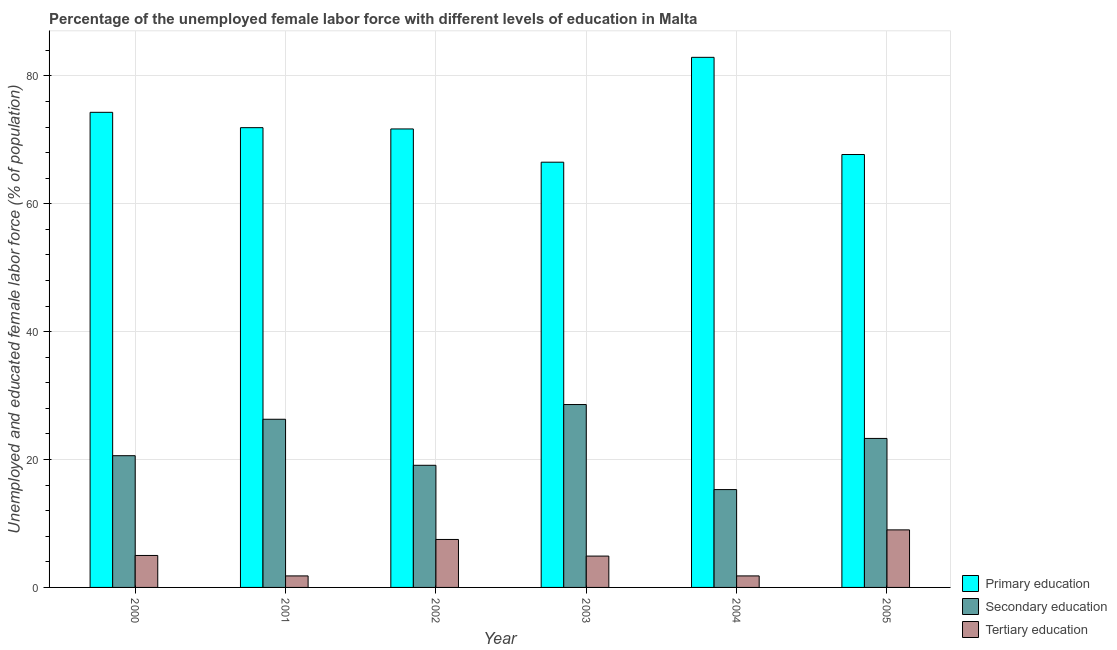How many different coloured bars are there?
Provide a succinct answer. 3. How many groups of bars are there?
Offer a very short reply. 6. Are the number of bars per tick equal to the number of legend labels?
Provide a short and direct response. Yes. Are the number of bars on each tick of the X-axis equal?
Ensure brevity in your answer.  Yes. How many bars are there on the 4th tick from the right?
Ensure brevity in your answer.  3. In how many cases, is the number of bars for a given year not equal to the number of legend labels?
Offer a terse response. 0. What is the percentage of female labor force who received tertiary education in 2003?
Ensure brevity in your answer.  4.9. Across all years, what is the maximum percentage of female labor force who received secondary education?
Your answer should be very brief. 28.6. Across all years, what is the minimum percentage of female labor force who received primary education?
Your answer should be compact. 66.5. In which year was the percentage of female labor force who received secondary education maximum?
Provide a short and direct response. 2003. In which year was the percentage of female labor force who received secondary education minimum?
Give a very brief answer. 2004. What is the total percentage of female labor force who received secondary education in the graph?
Keep it short and to the point. 133.2. What is the difference between the percentage of female labor force who received tertiary education in 2001 and that in 2002?
Your response must be concise. -5.7. What is the difference between the percentage of female labor force who received secondary education in 2003 and the percentage of female labor force who received tertiary education in 2004?
Offer a very short reply. 13.3. What is the average percentage of female labor force who received tertiary education per year?
Provide a succinct answer. 5. In the year 2001, what is the difference between the percentage of female labor force who received secondary education and percentage of female labor force who received primary education?
Provide a short and direct response. 0. What is the ratio of the percentage of female labor force who received tertiary education in 2001 to that in 2003?
Offer a very short reply. 0.37. Is the percentage of female labor force who received tertiary education in 2004 less than that in 2005?
Your answer should be very brief. Yes. Is the difference between the percentage of female labor force who received primary education in 2000 and 2003 greater than the difference between the percentage of female labor force who received tertiary education in 2000 and 2003?
Your answer should be compact. No. What is the difference between the highest and the lowest percentage of female labor force who received primary education?
Your answer should be very brief. 16.4. In how many years, is the percentage of female labor force who received tertiary education greater than the average percentage of female labor force who received tertiary education taken over all years?
Make the answer very short. 3. What does the 2nd bar from the left in 2002 represents?
Offer a very short reply. Secondary education. What does the 2nd bar from the right in 2004 represents?
Offer a terse response. Secondary education. Is it the case that in every year, the sum of the percentage of female labor force who received primary education and percentage of female labor force who received secondary education is greater than the percentage of female labor force who received tertiary education?
Offer a very short reply. Yes. How many years are there in the graph?
Ensure brevity in your answer.  6. What is the difference between two consecutive major ticks on the Y-axis?
Your response must be concise. 20. Does the graph contain any zero values?
Keep it short and to the point. No. Does the graph contain grids?
Ensure brevity in your answer.  Yes. Where does the legend appear in the graph?
Your response must be concise. Bottom right. What is the title of the graph?
Your answer should be compact. Percentage of the unemployed female labor force with different levels of education in Malta. Does "Manufactures" appear as one of the legend labels in the graph?
Offer a very short reply. No. What is the label or title of the X-axis?
Provide a succinct answer. Year. What is the label or title of the Y-axis?
Your answer should be compact. Unemployed and educated female labor force (% of population). What is the Unemployed and educated female labor force (% of population) in Primary education in 2000?
Offer a terse response. 74.3. What is the Unemployed and educated female labor force (% of population) of Secondary education in 2000?
Provide a short and direct response. 20.6. What is the Unemployed and educated female labor force (% of population) of Tertiary education in 2000?
Provide a short and direct response. 5. What is the Unemployed and educated female labor force (% of population) in Primary education in 2001?
Your answer should be compact. 71.9. What is the Unemployed and educated female labor force (% of population) in Secondary education in 2001?
Your answer should be very brief. 26.3. What is the Unemployed and educated female labor force (% of population) of Tertiary education in 2001?
Provide a succinct answer. 1.8. What is the Unemployed and educated female labor force (% of population) of Primary education in 2002?
Your answer should be very brief. 71.7. What is the Unemployed and educated female labor force (% of population) in Secondary education in 2002?
Your response must be concise. 19.1. What is the Unemployed and educated female labor force (% of population) in Tertiary education in 2002?
Make the answer very short. 7.5. What is the Unemployed and educated female labor force (% of population) in Primary education in 2003?
Make the answer very short. 66.5. What is the Unemployed and educated female labor force (% of population) in Secondary education in 2003?
Offer a terse response. 28.6. What is the Unemployed and educated female labor force (% of population) of Tertiary education in 2003?
Keep it short and to the point. 4.9. What is the Unemployed and educated female labor force (% of population) of Primary education in 2004?
Offer a very short reply. 82.9. What is the Unemployed and educated female labor force (% of population) in Secondary education in 2004?
Provide a short and direct response. 15.3. What is the Unemployed and educated female labor force (% of population) of Tertiary education in 2004?
Offer a terse response. 1.8. What is the Unemployed and educated female labor force (% of population) of Primary education in 2005?
Make the answer very short. 67.7. What is the Unemployed and educated female labor force (% of population) in Secondary education in 2005?
Keep it short and to the point. 23.3. Across all years, what is the maximum Unemployed and educated female labor force (% of population) in Primary education?
Offer a very short reply. 82.9. Across all years, what is the maximum Unemployed and educated female labor force (% of population) of Secondary education?
Offer a very short reply. 28.6. Across all years, what is the minimum Unemployed and educated female labor force (% of population) of Primary education?
Provide a short and direct response. 66.5. Across all years, what is the minimum Unemployed and educated female labor force (% of population) of Secondary education?
Make the answer very short. 15.3. Across all years, what is the minimum Unemployed and educated female labor force (% of population) of Tertiary education?
Offer a very short reply. 1.8. What is the total Unemployed and educated female labor force (% of population) in Primary education in the graph?
Your answer should be compact. 435. What is the total Unemployed and educated female labor force (% of population) of Secondary education in the graph?
Give a very brief answer. 133.2. What is the total Unemployed and educated female labor force (% of population) of Tertiary education in the graph?
Give a very brief answer. 30. What is the difference between the Unemployed and educated female labor force (% of population) of Tertiary education in 2000 and that in 2001?
Make the answer very short. 3.2. What is the difference between the Unemployed and educated female labor force (% of population) in Primary education in 2000 and that in 2002?
Provide a short and direct response. 2.6. What is the difference between the Unemployed and educated female labor force (% of population) in Secondary education in 2000 and that in 2002?
Ensure brevity in your answer.  1.5. What is the difference between the Unemployed and educated female labor force (% of population) of Tertiary education in 2000 and that in 2002?
Your response must be concise. -2.5. What is the difference between the Unemployed and educated female labor force (% of population) in Primary education in 2000 and that in 2003?
Your answer should be very brief. 7.8. What is the difference between the Unemployed and educated female labor force (% of population) of Secondary education in 2000 and that in 2003?
Make the answer very short. -8. What is the difference between the Unemployed and educated female labor force (% of population) of Primary education in 2000 and that in 2004?
Make the answer very short. -8.6. What is the difference between the Unemployed and educated female labor force (% of population) of Secondary education in 2000 and that in 2004?
Provide a short and direct response. 5.3. What is the difference between the Unemployed and educated female labor force (% of population) in Primary education in 2000 and that in 2005?
Give a very brief answer. 6.6. What is the difference between the Unemployed and educated female labor force (% of population) in Primary education in 2001 and that in 2002?
Your answer should be compact. 0.2. What is the difference between the Unemployed and educated female labor force (% of population) of Primary education in 2001 and that in 2003?
Offer a terse response. 5.4. What is the difference between the Unemployed and educated female labor force (% of population) of Primary education in 2001 and that in 2004?
Keep it short and to the point. -11. What is the difference between the Unemployed and educated female labor force (% of population) of Secondary education in 2001 and that in 2004?
Your response must be concise. 11. What is the difference between the Unemployed and educated female labor force (% of population) in Tertiary education in 2001 and that in 2004?
Provide a short and direct response. 0. What is the difference between the Unemployed and educated female labor force (% of population) in Tertiary education in 2001 and that in 2005?
Your answer should be compact. -7.2. What is the difference between the Unemployed and educated female labor force (% of population) of Primary education in 2002 and that in 2003?
Give a very brief answer. 5.2. What is the difference between the Unemployed and educated female labor force (% of population) in Tertiary education in 2002 and that in 2003?
Make the answer very short. 2.6. What is the difference between the Unemployed and educated female labor force (% of population) in Primary education in 2002 and that in 2004?
Offer a terse response. -11.2. What is the difference between the Unemployed and educated female labor force (% of population) in Tertiary education in 2002 and that in 2004?
Provide a short and direct response. 5.7. What is the difference between the Unemployed and educated female labor force (% of population) in Primary education in 2002 and that in 2005?
Give a very brief answer. 4. What is the difference between the Unemployed and educated female labor force (% of population) of Tertiary education in 2002 and that in 2005?
Offer a very short reply. -1.5. What is the difference between the Unemployed and educated female labor force (% of population) of Primary education in 2003 and that in 2004?
Your answer should be compact. -16.4. What is the difference between the Unemployed and educated female labor force (% of population) of Secondary education in 2003 and that in 2004?
Offer a very short reply. 13.3. What is the difference between the Unemployed and educated female labor force (% of population) in Tertiary education in 2003 and that in 2004?
Your answer should be very brief. 3.1. What is the difference between the Unemployed and educated female labor force (% of population) in Primary education in 2003 and that in 2005?
Keep it short and to the point. -1.2. What is the difference between the Unemployed and educated female labor force (% of population) in Secondary education in 2004 and that in 2005?
Offer a terse response. -8. What is the difference between the Unemployed and educated female labor force (% of population) of Tertiary education in 2004 and that in 2005?
Your answer should be very brief. -7.2. What is the difference between the Unemployed and educated female labor force (% of population) of Primary education in 2000 and the Unemployed and educated female labor force (% of population) of Tertiary education in 2001?
Your answer should be compact. 72.5. What is the difference between the Unemployed and educated female labor force (% of population) of Primary education in 2000 and the Unemployed and educated female labor force (% of population) of Secondary education in 2002?
Provide a succinct answer. 55.2. What is the difference between the Unemployed and educated female labor force (% of population) of Primary education in 2000 and the Unemployed and educated female labor force (% of population) of Tertiary education in 2002?
Keep it short and to the point. 66.8. What is the difference between the Unemployed and educated female labor force (% of population) of Secondary education in 2000 and the Unemployed and educated female labor force (% of population) of Tertiary education in 2002?
Provide a succinct answer. 13.1. What is the difference between the Unemployed and educated female labor force (% of population) in Primary education in 2000 and the Unemployed and educated female labor force (% of population) in Secondary education in 2003?
Your answer should be compact. 45.7. What is the difference between the Unemployed and educated female labor force (% of population) in Primary education in 2000 and the Unemployed and educated female labor force (% of population) in Tertiary education in 2003?
Provide a short and direct response. 69.4. What is the difference between the Unemployed and educated female labor force (% of population) in Secondary education in 2000 and the Unemployed and educated female labor force (% of population) in Tertiary education in 2003?
Your answer should be very brief. 15.7. What is the difference between the Unemployed and educated female labor force (% of population) of Primary education in 2000 and the Unemployed and educated female labor force (% of population) of Tertiary education in 2004?
Your answer should be compact. 72.5. What is the difference between the Unemployed and educated female labor force (% of population) of Secondary education in 2000 and the Unemployed and educated female labor force (% of population) of Tertiary education in 2004?
Your response must be concise. 18.8. What is the difference between the Unemployed and educated female labor force (% of population) of Primary education in 2000 and the Unemployed and educated female labor force (% of population) of Tertiary education in 2005?
Make the answer very short. 65.3. What is the difference between the Unemployed and educated female labor force (% of population) of Secondary education in 2000 and the Unemployed and educated female labor force (% of population) of Tertiary education in 2005?
Offer a terse response. 11.6. What is the difference between the Unemployed and educated female labor force (% of population) of Primary education in 2001 and the Unemployed and educated female labor force (% of population) of Secondary education in 2002?
Give a very brief answer. 52.8. What is the difference between the Unemployed and educated female labor force (% of population) in Primary education in 2001 and the Unemployed and educated female labor force (% of population) in Tertiary education in 2002?
Provide a succinct answer. 64.4. What is the difference between the Unemployed and educated female labor force (% of population) of Secondary education in 2001 and the Unemployed and educated female labor force (% of population) of Tertiary education in 2002?
Make the answer very short. 18.8. What is the difference between the Unemployed and educated female labor force (% of population) of Primary education in 2001 and the Unemployed and educated female labor force (% of population) of Secondary education in 2003?
Your answer should be compact. 43.3. What is the difference between the Unemployed and educated female labor force (% of population) of Primary education in 2001 and the Unemployed and educated female labor force (% of population) of Tertiary education in 2003?
Provide a succinct answer. 67. What is the difference between the Unemployed and educated female labor force (% of population) of Secondary education in 2001 and the Unemployed and educated female labor force (% of population) of Tertiary education in 2003?
Your answer should be very brief. 21.4. What is the difference between the Unemployed and educated female labor force (% of population) of Primary education in 2001 and the Unemployed and educated female labor force (% of population) of Secondary education in 2004?
Provide a succinct answer. 56.6. What is the difference between the Unemployed and educated female labor force (% of population) of Primary education in 2001 and the Unemployed and educated female labor force (% of population) of Tertiary education in 2004?
Ensure brevity in your answer.  70.1. What is the difference between the Unemployed and educated female labor force (% of population) of Secondary education in 2001 and the Unemployed and educated female labor force (% of population) of Tertiary education in 2004?
Give a very brief answer. 24.5. What is the difference between the Unemployed and educated female labor force (% of population) of Primary education in 2001 and the Unemployed and educated female labor force (% of population) of Secondary education in 2005?
Keep it short and to the point. 48.6. What is the difference between the Unemployed and educated female labor force (% of population) of Primary education in 2001 and the Unemployed and educated female labor force (% of population) of Tertiary education in 2005?
Your response must be concise. 62.9. What is the difference between the Unemployed and educated female labor force (% of population) of Secondary education in 2001 and the Unemployed and educated female labor force (% of population) of Tertiary education in 2005?
Give a very brief answer. 17.3. What is the difference between the Unemployed and educated female labor force (% of population) in Primary education in 2002 and the Unemployed and educated female labor force (% of population) in Secondary education in 2003?
Offer a very short reply. 43.1. What is the difference between the Unemployed and educated female labor force (% of population) in Primary education in 2002 and the Unemployed and educated female labor force (% of population) in Tertiary education in 2003?
Ensure brevity in your answer.  66.8. What is the difference between the Unemployed and educated female labor force (% of population) of Primary education in 2002 and the Unemployed and educated female labor force (% of population) of Secondary education in 2004?
Your response must be concise. 56.4. What is the difference between the Unemployed and educated female labor force (% of population) in Primary education in 2002 and the Unemployed and educated female labor force (% of population) in Tertiary education in 2004?
Provide a succinct answer. 69.9. What is the difference between the Unemployed and educated female labor force (% of population) in Secondary education in 2002 and the Unemployed and educated female labor force (% of population) in Tertiary education in 2004?
Your answer should be very brief. 17.3. What is the difference between the Unemployed and educated female labor force (% of population) in Primary education in 2002 and the Unemployed and educated female labor force (% of population) in Secondary education in 2005?
Ensure brevity in your answer.  48.4. What is the difference between the Unemployed and educated female labor force (% of population) of Primary education in 2002 and the Unemployed and educated female labor force (% of population) of Tertiary education in 2005?
Give a very brief answer. 62.7. What is the difference between the Unemployed and educated female labor force (% of population) of Secondary education in 2002 and the Unemployed and educated female labor force (% of population) of Tertiary education in 2005?
Keep it short and to the point. 10.1. What is the difference between the Unemployed and educated female labor force (% of population) of Primary education in 2003 and the Unemployed and educated female labor force (% of population) of Secondary education in 2004?
Your answer should be very brief. 51.2. What is the difference between the Unemployed and educated female labor force (% of population) of Primary education in 2003 and the Unemployed and educated female labor force (% of population) of Tertiary education in 2004?
Your response must be concise. 64.7. What is the difference between the Unemployed and educated female labor force (% of population) of Secondary education in 2003 and the Unemployed and educated female labor force (% of population) of Tertiary education in 2004?
Your answer should be compact. 26.8. What is the difference between the Unemployed and educated female labor force (% of population) in Primary education in 2003 and the Unemployed and educated female labor force (% of population) in Secondary education in 2005?
Your answer should be compact. 43.2. What is the difference between the Unemployed and educated female labor force (% of population) in Primary education in 2003 and the Unemployed and educated female labor force (% of population) in Tertiary education in 2005?
Offer a terse response. 57.5. What is the difference between the Unemployed and educated female labor force (% of population) of Secondary education in 2003 and the Unemployed and educated female labor force (% of population) of Tertiary education in 2005?
Ensure brevity in your answer.  19.6. What is the difference between the Unemployed and educated female labor force (% of population) in Primary education in 2004 and the Unemployed and educated female labor force (% of population) in Secondary education in 2005?
Provide a short and direct response. 59.6. What is the difference between the Unemployed and educated female labor force (% of population) of Primary education in 2004 and the Unemployed and educated female labor force (% of population) of Tertiary education in 2005?
Make the answer very short. 73.9. What is the average Unemployed and educated female labor force (% of population) in Primary education per year?
Keep it short and to the point. 72.5. What is the average Unemployed and educated female labor force (% of population) in Tertiary education per year?
Make the answer very short. 5. In the year 2000, what is the difference between the Unemployed and educated female labor force (% of population) in Primary education and Unemployed and educated female labor force (% of population) in Secondary education?
Provide a succinct answer. 53.7. In the year 2000, what is the difference between the Unemployed and educated female labor force (% of population) in Primary education and Unemployed and educated female labor force (% of population) in Tertiary education?
Ensure brevity in your answer.  69.3. In the year 2000, what is the difference between the Unemployed and educated female labor force (% of population) in Secondary education and Unemployed and educated female labor force (% of population) in Tertiary education?
Your answer should be compact. 15.6. In the year 2001, what is the difference between the Unemployed and educated female labor force (% of population) in Primary education and Unemployed and educated female labor force (% of population) in Secondary education?
Provide a short and direct response. 45.6. In the year 2001, what is the difference between the Unemployed and educated female labor force (% of population) in Primary education and Unemployed and educated female labor force (% of population) in Tertiary education?
Give a very brief answer. 70.1. In the year 2001, what is the difference between the Unemployed and educated female labor force (% of population) in Secondary education and Unemployed and educated female labor force (% of population) in Tertiary education?
Keep it short and to the point. 24.5. In the year 2002, what is the difference between the Unemployed and educated female labor force (% of population) of Primary education and Unemployed and educated female labor force (% of population) of Secondary education?
Provide a short and direct response. 52.6. In the year 2002, what is the difference between the Unemployed and educated female labor force (% of population) of Primary education and Unemployed and educated female labor force (% of population) of Tertiary education?
Provide a succinct answer. 64.2. In the year 2002, what is the difference between the Unemployed and educated female labor force (% of population) in Secondary education and Unemployed and educated female labor force (% of population) in Tertiary education?
Offer a very short reply. 11.6. In the year 2003, what is the difference between the Unemployed and educated female labor force (% of population) of Primary education and Unemployed and educated female labor force (% of population) of Secondary education?
Your answer should be compact. 37.9. In the year 2003, what is the difference between the Unemployed and educated female labor force (% of population) of Primary education and Unemployed and educated female labor force (% of population) of Tertiary education?
Give a very brief answer. 61.6. In the year 2003, what is the difference between the Unemployed and educated female labor force (% of population) of Secondary education and Unemployed and educated female labor force (% of population) of Tertiary education?
Your response must be concise. 23.7. In the year 2004, what is the difference between the Unemployed and educated female labor force (% of population) in Primary education and Unemployed and educated female labor force (% of population) in Secondary education?
Keep it short and to the point. 67.6. In the year 2004, what is the difference between the Unemployed and educated female labor force (% of population) in Primary education and Unemployed and educated female labor force (% of population) in Tertiary education?
Your answer should be compact. 81.1. In the year 2004, what is the difference between the Unemployed and educated female labor force (% of population) of Secondary education and Unemployed and educated female labor force (% of population) of Tertiary education?
Ensure brevity in your answer.  13.5. In the year 2005, what is the difference between the Unemployed and educated female labor force (% of population) in Primary education and Unemployed and educated female labor force (% of population) in Secondary education?
Provide a succinct answer. 44.4. In the year 2005, what is the difference between the Unemployed and educated female labor force (% of population) of Primary education and Unemployed and educated female labor force (% of population) of Tertiary education?
Give a very brief answer. 58.7. In the year 2005, what is the difference between the Unemployed and educated female labor force (% of population) of Secondary education and Unemployed and educated female labor force (% of population) of Tertiary education?
Make the answer very short. 14.3. What is the ratio of the Unemployed and educated female labor force (% of population) of Primary education in 2000 to that in 2001?
Ensure brevity in your answer.  1.03. What is the ratio of the Unemployed and educated female labor force (% of population) in Secondary education in 2000 to that in 2001?
Ensure brevity in your answer.  0.78. What is the ratio of the Unemployed and educated female labor force (% of population) in Tertiary education in 2000 to that in 2001?
Your response must be concise. 2.78. What is the ratio of the Unemployed and educated female labor force (% of population) of Primary education in 2000 to that in 2002?
Your answer should be very brief. 1.04. What is the ratio of the Unemployed and educated female labor force (% of population) of Secondary education in 2000 to that in 2002?
Keep it short and to the point. 1.08. What is the ratio of the Unemployed and educated female labor force (% of population) of Tertiary education in 2000 to that in 2002?
Provide a short and direct response. 0.67. What is the ratio of the Unemployed and educated female labor force (% of population) of Primary education in 2000 to that in 2003?
Your answer should be compact. 1.12. What is the ratio of the Unemployed and educated female labor force (% of population) in Secondary education in 2000 to that in 2003?
Ensure brevity in your answer.  0.72. What is the ratio of the Unemployed and educated female labor force (% of population) of Tertiary education in 2000 to that in 2003?
Your response must be concise. 1.02. What is the ratio of the Unemployed and educated female labor force (% of population) of Primary education in 2000 to that in 2004?
Provide a succinct answer. 0.9. What is the ratio of the Unemployed and educated female labor force (% of population) of Secondary education in 2000 to that in 2004?
Your response must be concise. 1.35. What is the ratio of the Unemployed and educated female labor force (% of population) of Tertiary education in 2000 to that in 2004?
Keep it short and to the point. 2.78. What is the ratio of the Unemployed and educated female labor force (% of population) in Primary education in 2000 to that in 2005?
Give a very brief answer. 1.1. What is the ratio of the Unemployed and educated female labor force (% of population) of Secondary education in 2000 to that in 2005?
Provide a short and direct response. 0.88. What is the ratio of the Unemployed and educated female labor force (% of population) of Tertiary education in 2000 to that in 2005?
Ensure brevity in your answer.  0.56. What is the ratio of the Unemployed and educated female labor force (% of population) of Secondary education in 2001 to that in 2002?
Your answer should be compact. 1.38. What is the ratio of the Unemployed and educated female labor force (% of population) of Tertiary education in 2001 to that in 2002?
Provide a succinct answer. 0.24. What is the ratio of the Unemployed and educated female labor force (% of population) of Primary education in 2001 to that in 2003?
Provide a short and direct response. 1.08. What is the ratio of the Unemployed and educated female labor force (% of population) in Secondary education in 2001 to that in 2003?
Give a very brief answer. 0.92. What is the ratio of the Unemployed and educated female labor force (% of population) in Tertiary education in 2001 to that in 2003?
Offer a terse response. 0.37. What is the ratio of the Unemployed and educated female labor force (% of population) in Primary education in 2001 to that in 2004?
Offer a very short reply. 0.87. What is the ratio of the Unemployed and educated female labor force (% of population) in Secondary education in 2001 to that in 2004?
Your answer should be compact. 1.72. What is the ratio of the Unemployed and educated female labor force (% of population) of Primary education in 2001 to that in 2005?
Offer a terse response. 1.06. What is the ratio of the Unemployed and educated female labor force (% of population) of Secondary education in 2001 to that in 2005?
Keep it short and to the point. 1.13. What is the ratio of the Unemployed and educated female labor force (% of population) in Tertiary education in 2001 to that in 2005?
Offer a very short reply. 0.2. What is the ratio of the Unemployed and educated female labor force (% of population) of Primary education in 2002 to that in 2003?
Your response must be concise. 1.08. What is the ratio of the Unemployed and educated female labor force (% of population) in Secondary education in 2002 to that in 2003?
Keep it short and to the point. 0.67. What is the ratio of the Unemployed and educated female labor force (% of population) in Tertiary education in 2002 to that in 2003?
Your response must be concise. 1.53. What is the ratio of the Unemployed and educated female labor force (% of population) in Primary education in 2002 to that in 2004?
Provide a succinct answer. 0.86. What is the ratio of the Unemployed and educated female labor force (% of population) of Secondary education in 2002 to that in 2004?
Offer a terse response. 1.25. What is the ratio of the Unemployed and educated female labor force (% of population) in Tertiary education in 2002 to that in 2004?
Keep it short and to the point. 4.17. What is the ratio of the Unemployed and educated female labor force (% of population) in Primary education in 2002 to that in 2005?
Provide a short and direct response. 1.06. What is the ratio of the Unemployed and educated female labor force (% of population) in Secondary education in 2002 to that in 2005?
Keep it short and to the point. 0.82. What is the ratio of the Unemployed and educated female labor force (% of population) in Tertiary education in 2002 to that in 2005?
Keep it short and to the point. 0.83. What is the ratio of the Unemployed and educated female labor force (% of population) of Primary education in 2003 to that in 2004?
Make the answer very short. 0.8. What is the ratio of the Unemployed and educated female labor force (% of population) of Secondary education in 2003 to that in 2004?
Provide a short and direct response. 1.87. What is the ratio of the Unemployed and educated female labor force (% of population) in Tertiary education in 2003 to that in 2004?
Offer a very short reply. 2.72. What is the ratio of the Unemployed and educated female labor force (% of population) of Primary education in 2003 to that in 2005?
Make the answer very short. 0.98. What is the ratio of the Unemployed and educated female labor force (% of population) of Secondary education in 2003 to that in 2005?
Your answer should be very brief. 1.23. What is the ratio of the Unemployed and educated female labor force (% of population) of Tertiary education in 2003 to that in 2005?
Your answer should be compact. 0.54. What is the ratio of the Unemployed and educated female labor force (% of population) of Primary education in 2004 to that in 2005?
Provide a succinct answer. 1.22. What is the ratio of the Unemployed and educated female labor force (% of population) of Secondary education in 2004 to that in 2005?
Give a very brief answer. 0.66. What is the ratio of the Unemployed and educated female labor force (% of population) in Tertiary education in 2004 to that in 2005?
Provide a short and direct response. 0.2. What is the difference between the highest and the second highest Unemployed and educated female labor force (% of population) in Secondary education?
Keep it short and to the point. 2.3. What is the difference between the highest and the second highest Unemployed and educated female labor force (% of population) in Tertiary education?
Ensure brevity in your answer.  1.5. 